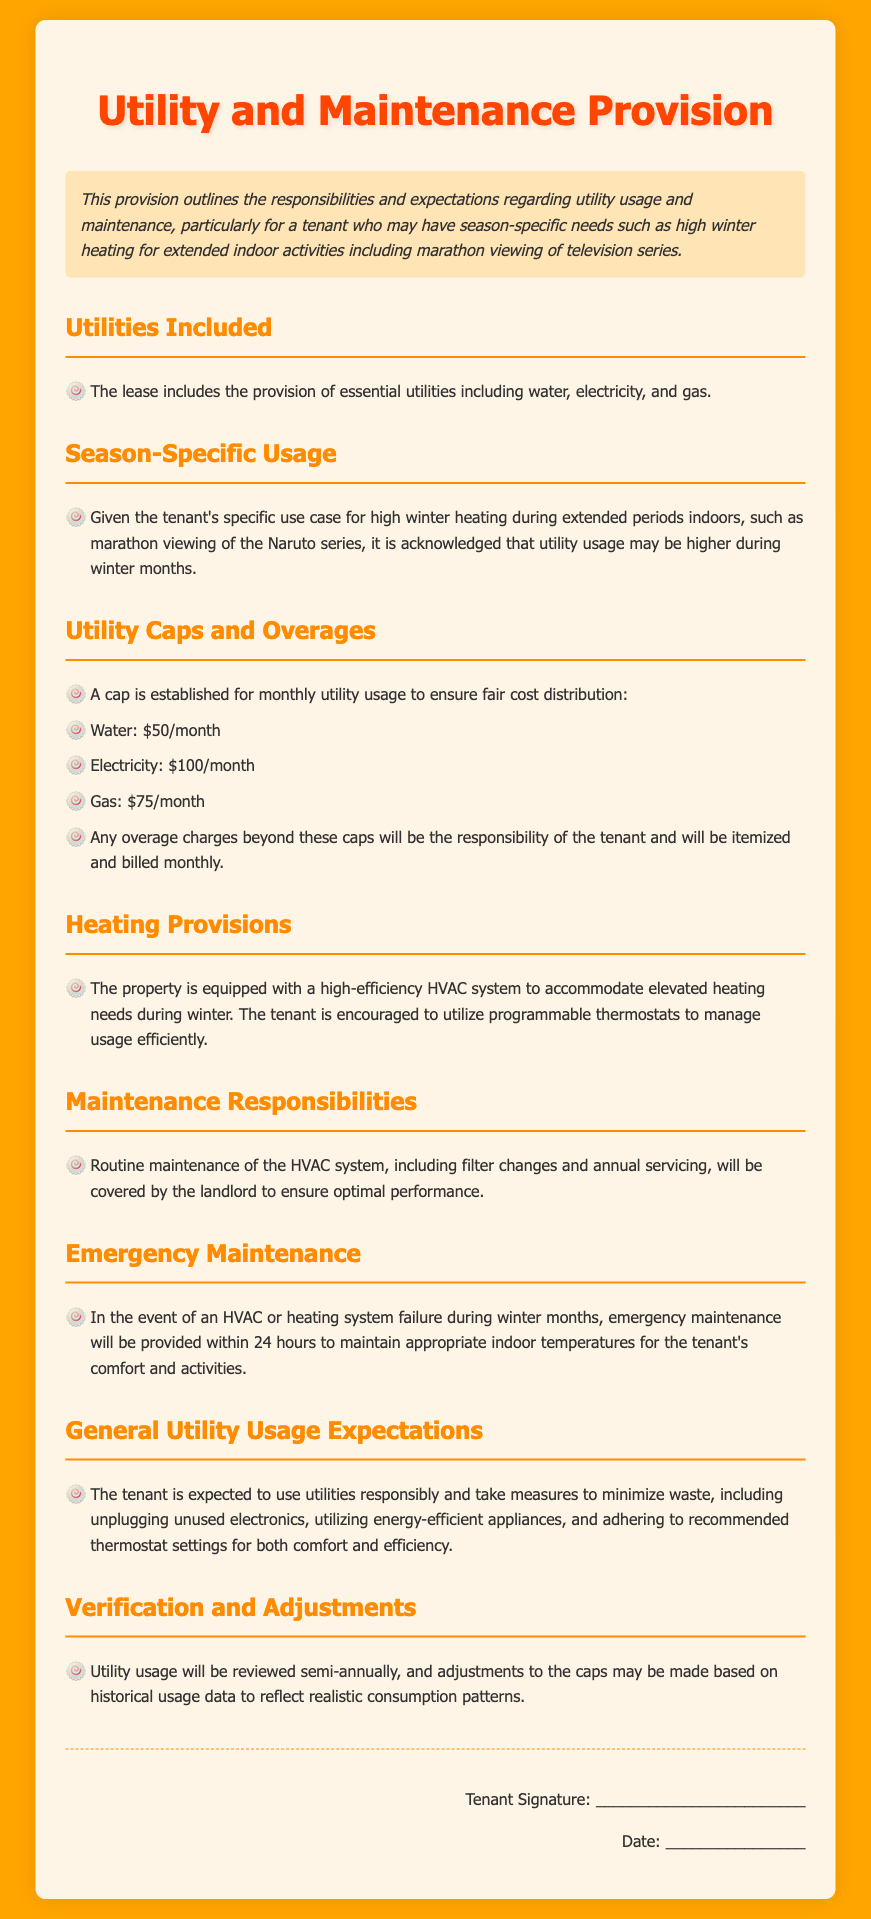What utilities are included in the lease? The lease specifies the included utilities as water, electricity, and gas.
Answer: water, electricity, gas What is the cap for electricity usage? The document states a monthly cap for electricity usage as a part of utility management.
Answer: $100/month What is the emergency maintenance response time during winter? The lease outlines the timeframe for emergency maintenance in case of heating failure during winter months.
Answer: 24 hours What is the monthly cap for gas usage? The document specifies a monthly limit for gas consumption to manage costs.
Answer: $75/month What heating system is mentioned in the lease? The lease references the type of heating system provided for high-efficiency heating during winter.
Answer: high-efficiency HVAC system What measure is mentioned for adjusting utility caps? The document states that utility usage is reviewed periodically to adjust caps based on specific criteria.
Answer: semi-annually How often will utility usage be reviewed? The lease outlines how frequently the utility usage will be assessed to ensure accuracy in billing.
Answer: semi-annually What is expected of the tenant in terms of utility usage? The lease describes the anticipated behavior regarding the use of utilities by the tenant.
Answer: use utilities responsibly What are the two main conditions for utility overages? The document specifies what's expected concerning overages beyond the established caps for utility usage.
Answer: responsibility and itemized billing 